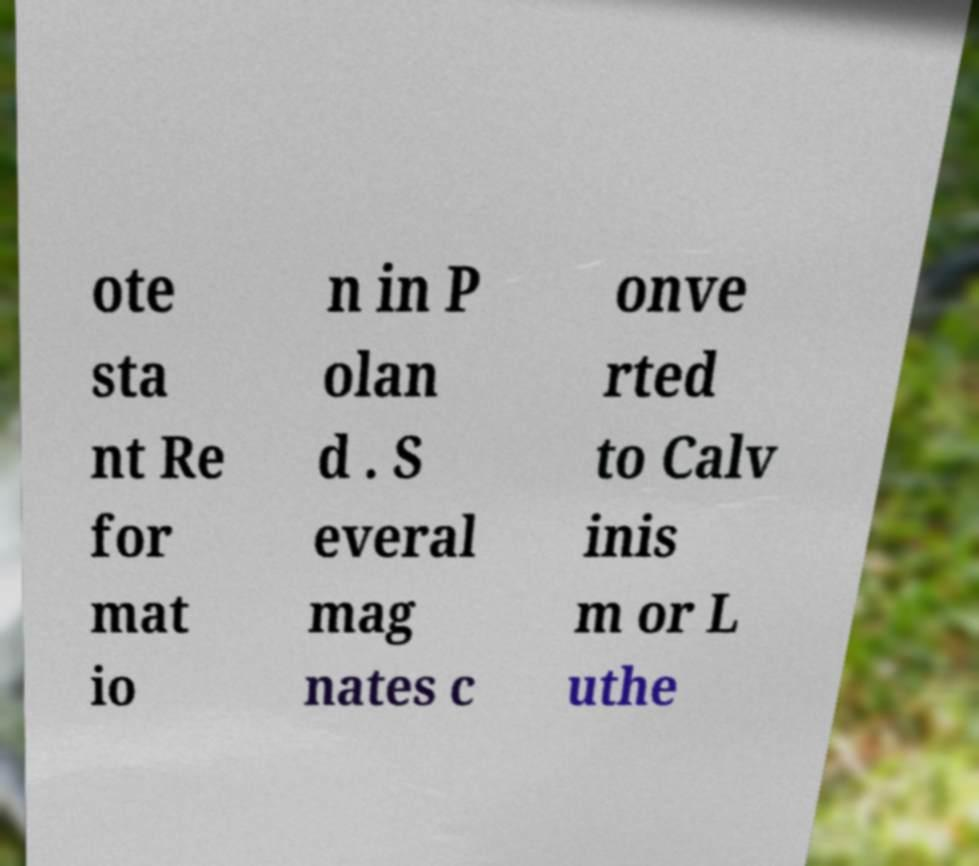For documentation purposes, I need the text within this image transcribed. Could you provide that? ote sta nt Re for mat io n in P olan d . S everal mag nates c onve rted to Calv inis m or L uthe 